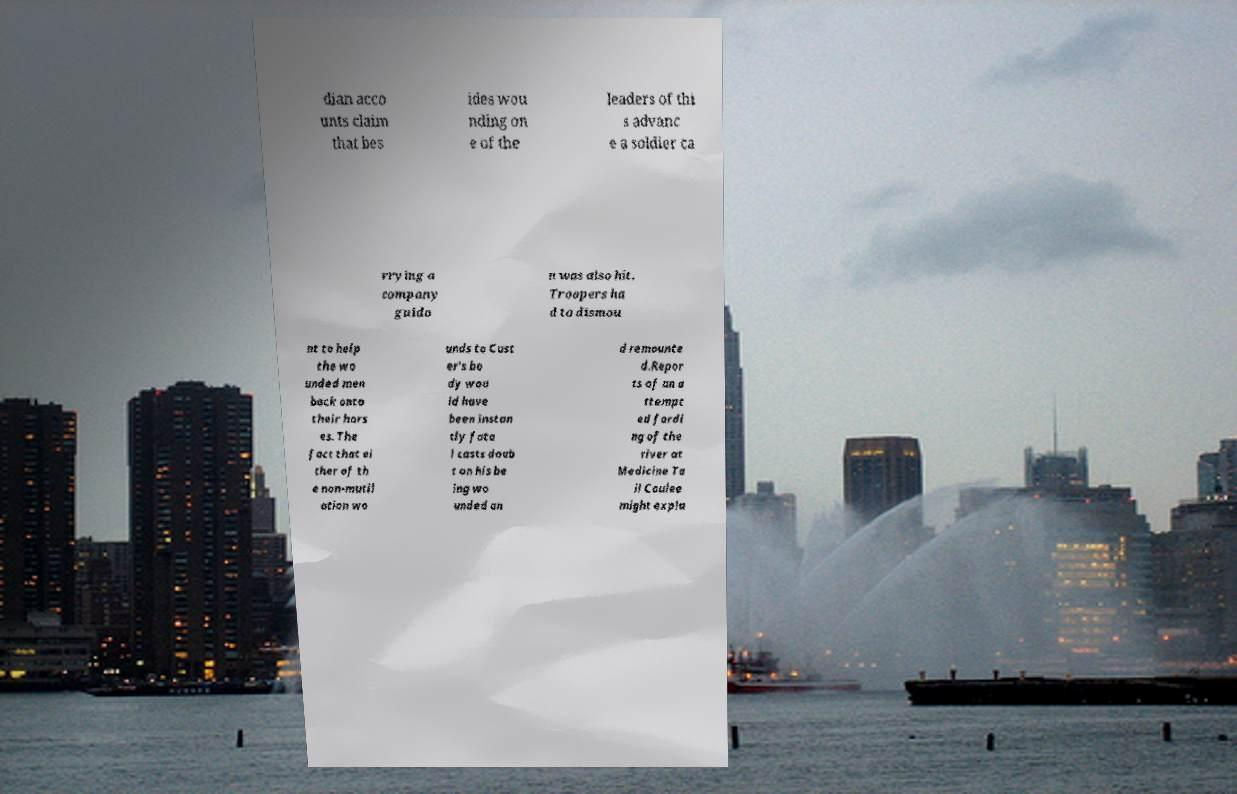What messages or text are displayed in this image? I need them in a readable, typed format. dian acco unts claim that bes ides wou nding on e of the leaders of thi s advanc e a soldier ca rrying a company guido n was also hit. Troopers ha d to dismou nt to help the wo unded men back onto their hors es. The fact that ei ther of th e non-mutil ation wo unds to Cust er's bo dy wou ld have been instan tly fata l casts doub t on his be ing wo unded an d remounte d.Repor ts of an a ttempt ed fordi ng of the river at Medicine Ta il Coulee might expla 